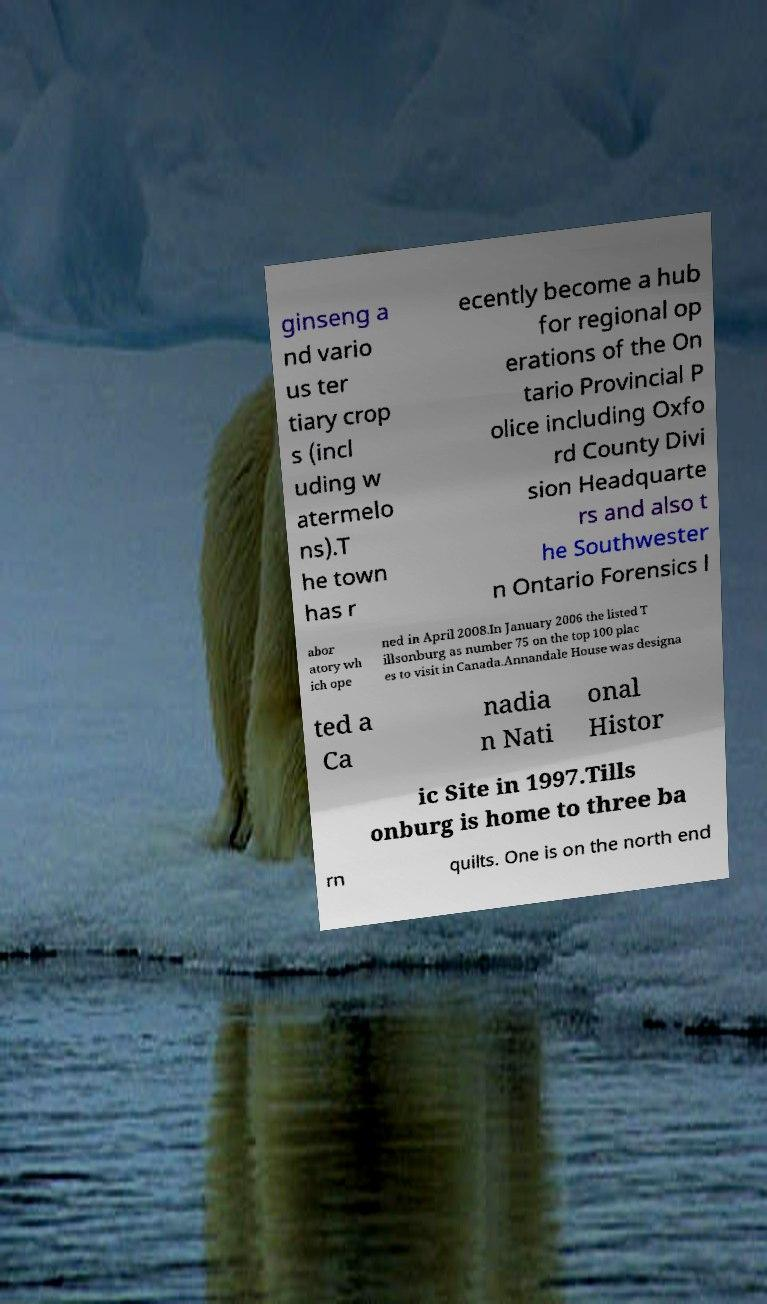Please identify and transcribe the text found in this image. ginseng a nd vario us ter tiary crop s (incl uding w atermelo ns).T he town has r ecently become a hub for regional op erations of the On tario Provincial P olice including Oxfo rd County Divi sion Headquarte rs and also t he Southwester n Ontario Forensics l abor atory wh ich ope ned in April 2008.In January 2006 the listed T illsonburg as number 75 on the top 100 plac es to visit in Canada.Annandale House was designa ted a Ca nadia n Nati onal Histor ic Site in 1997.Tills onburg is home to three ba rn quilts. One is on the north end 